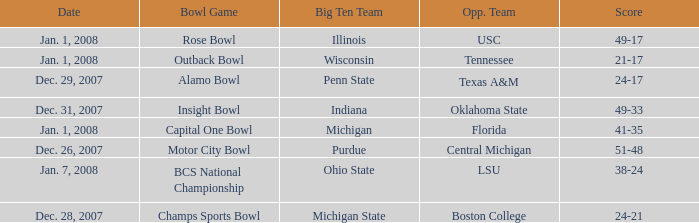Who was the opposing team in the game with a score of 21-17? Tennessee. 